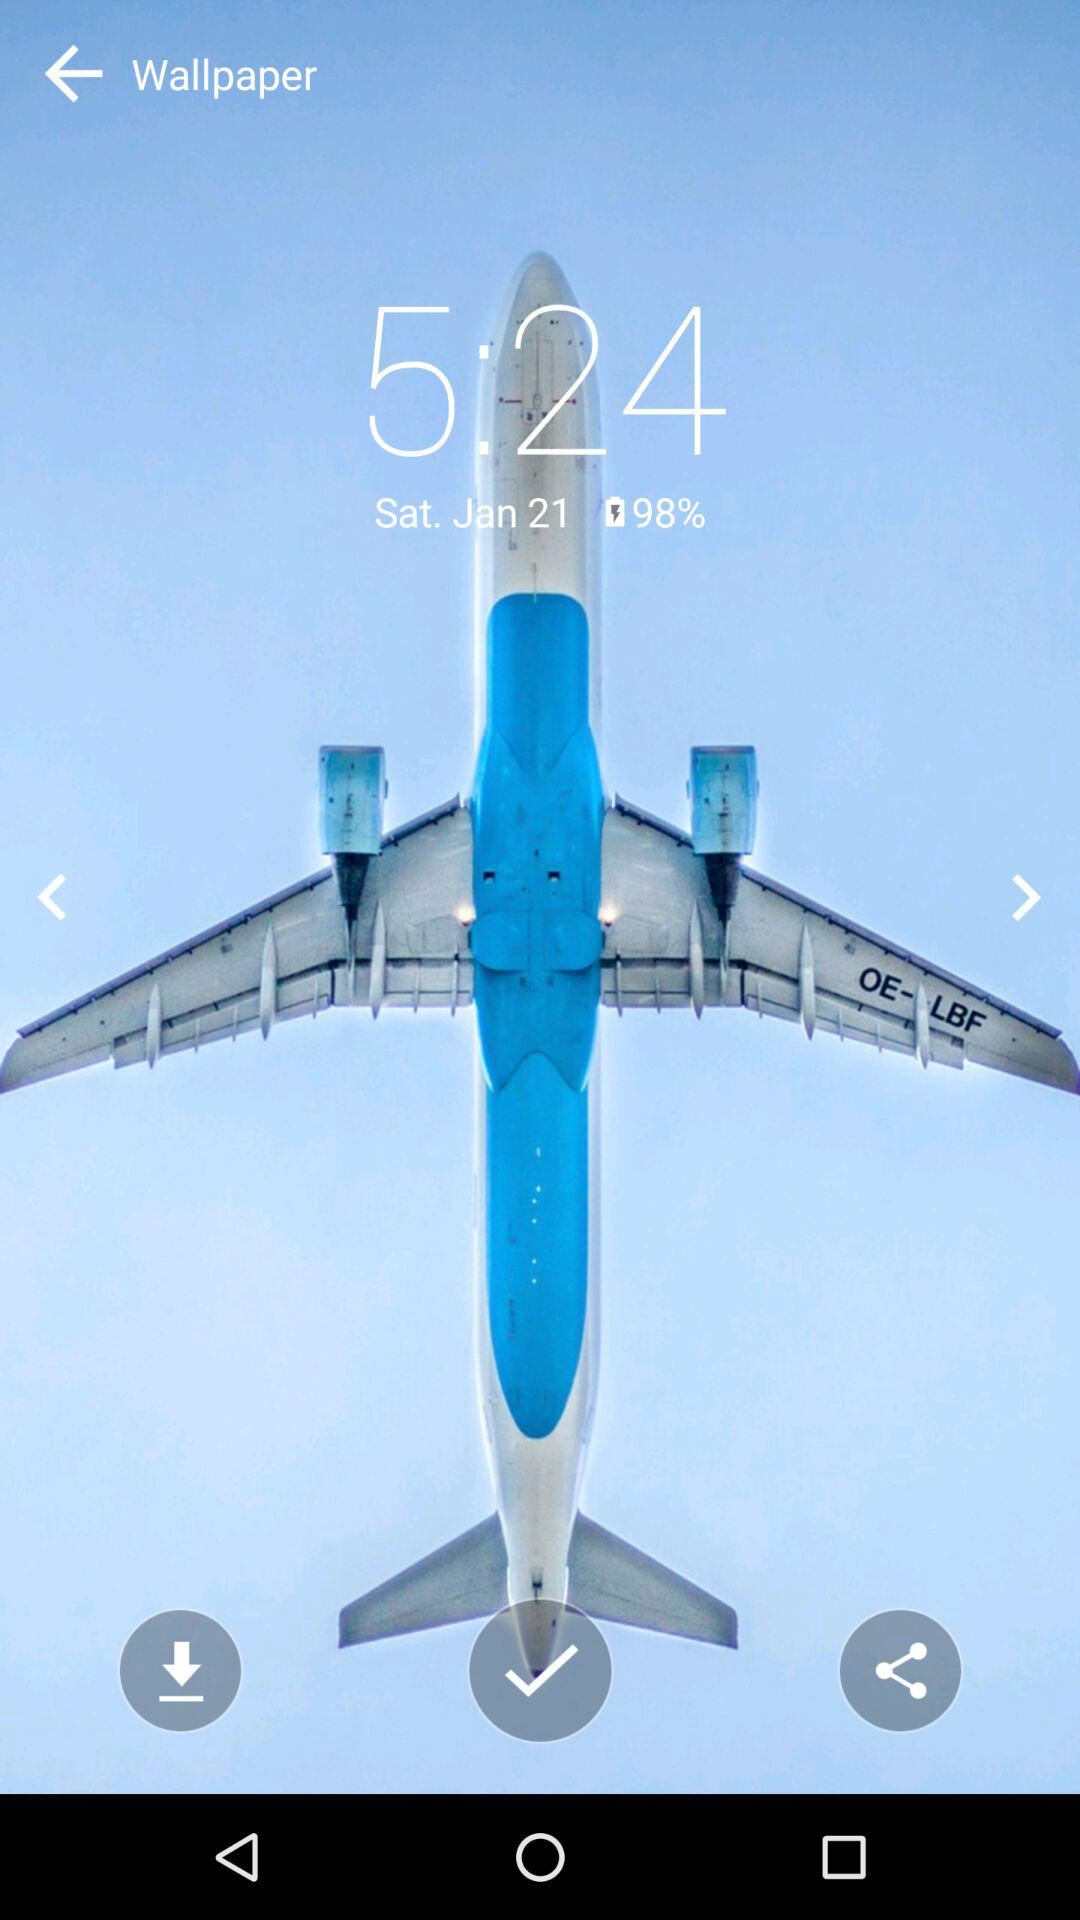What is the time? The time is 5:24. 